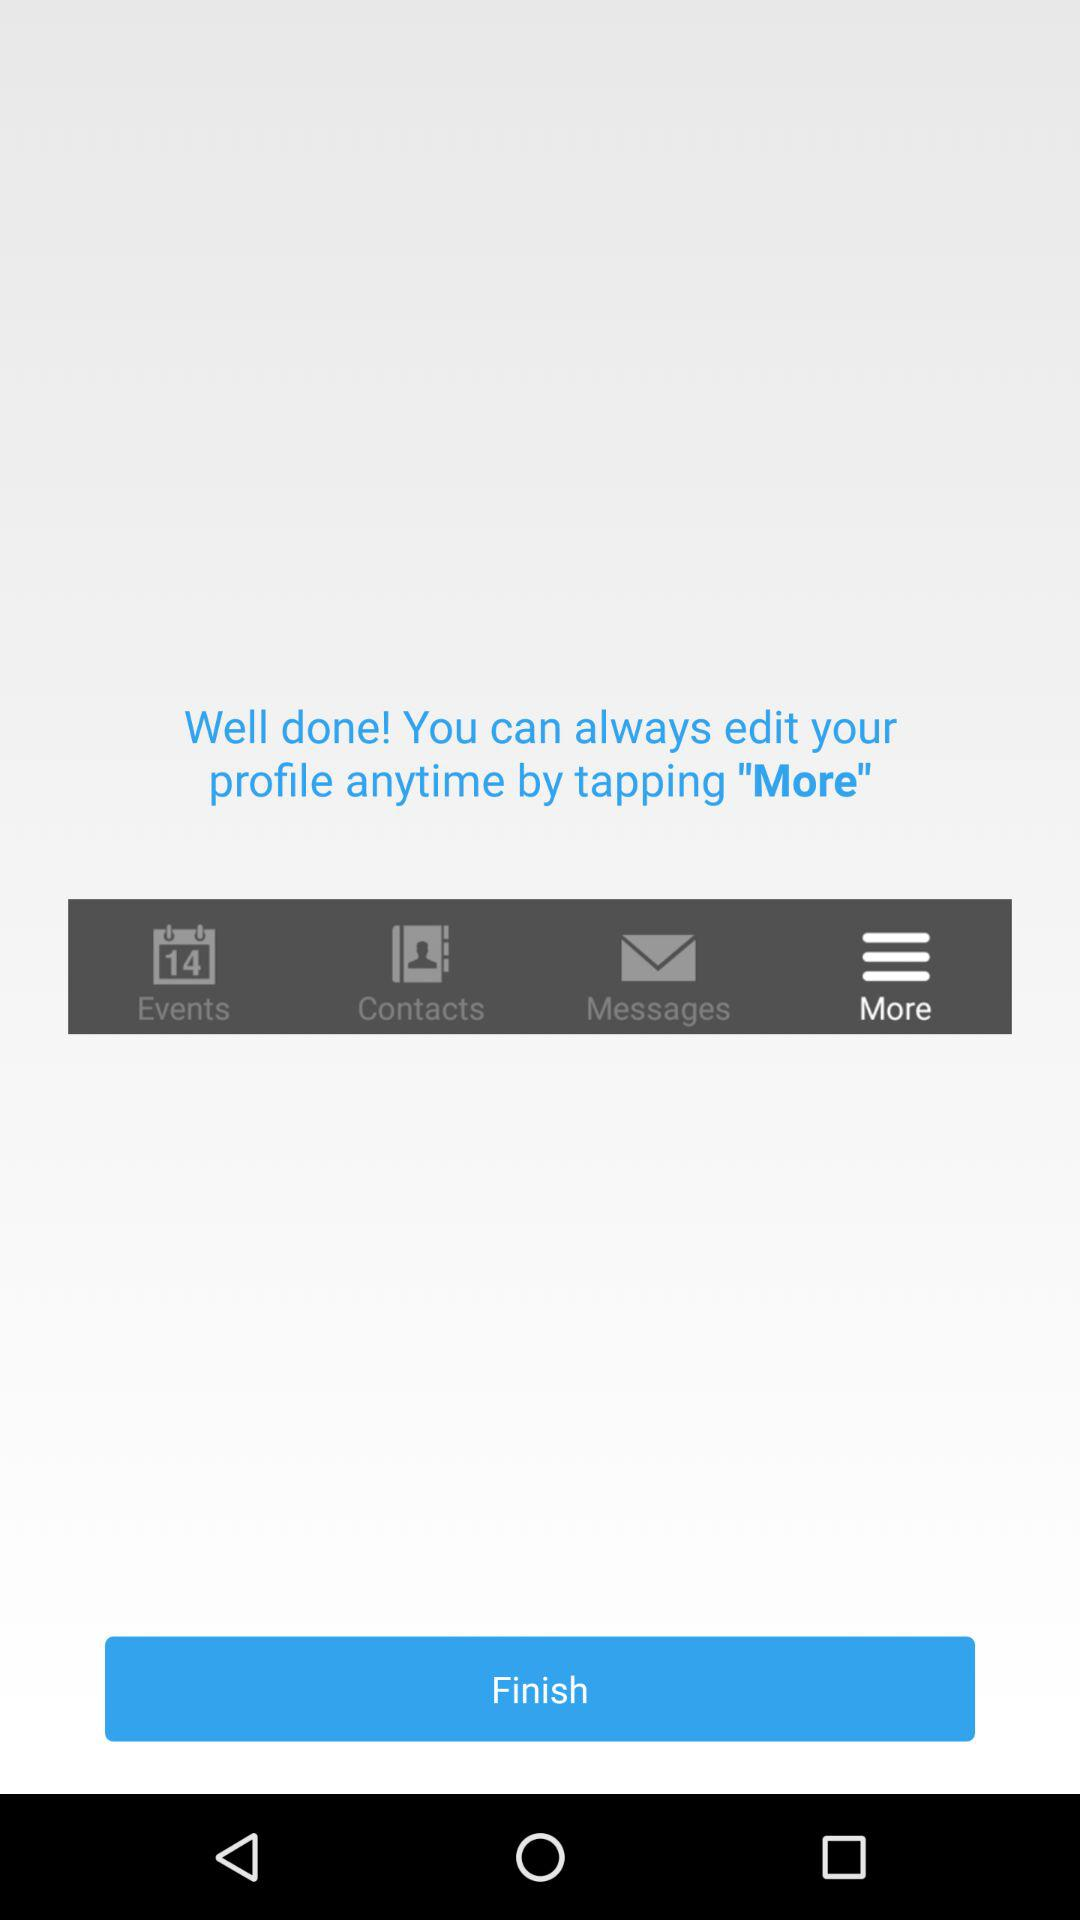What tab is selected? The selected tab is "More". 